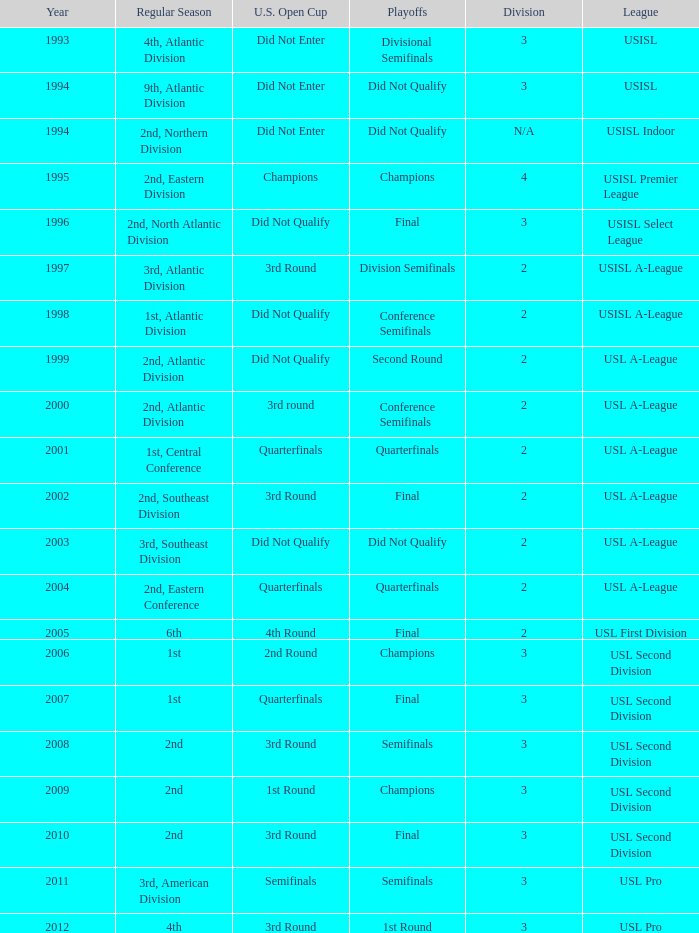What are all the playoffs for regular season is 1st, atlantic division Conference Semifinals. 